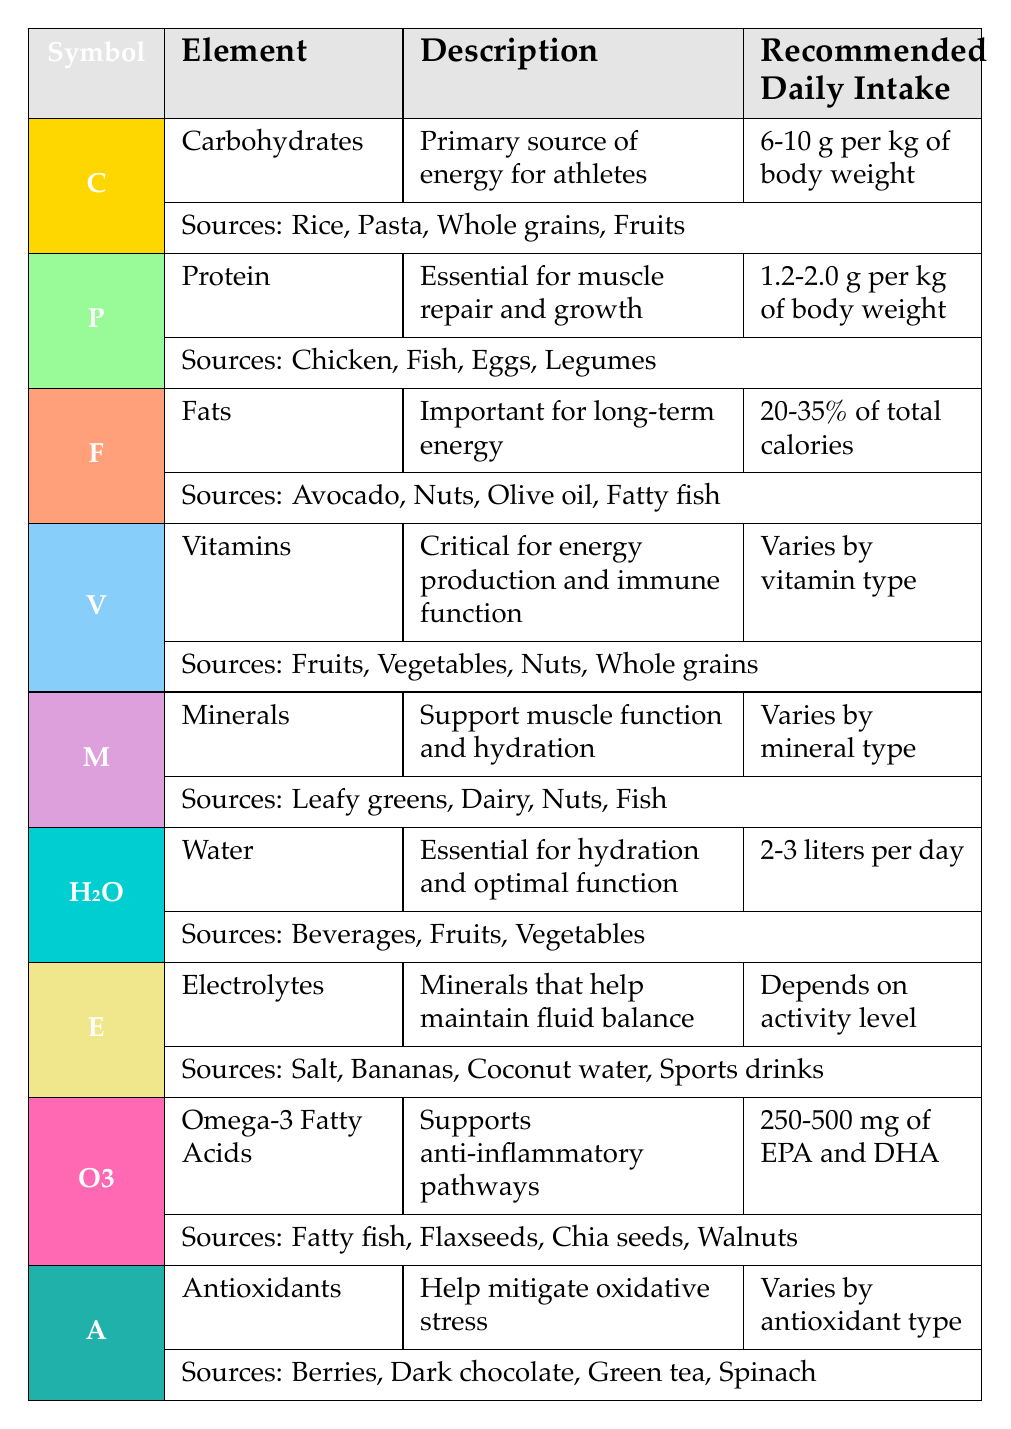What is the recommended daily intake of carbohydrates for athletes? The table specifies that the recommended daily intake of carbohydrates is 6-10 grams per kg of body weight. This can be directly found in the row for carbohydrates.
Answer: 6-10 grams per kg of body weight Which element is essential for muscle repair and growth? The table shows that protein is essential for muscle repair and growth, as stated in the description for protein.
Answer: Protein What is the primary source of energy for athletes? According to the table, carbohydrates are the primary source of energy for athletes, as highlighted in the carbohydrates' description.
Answer: Carbohydrates True or False: Fats are important for short-term energy needs in athletes. The table indicates that fats are important for long-term energy, especially in endurance sports, making the statement false.
Answer: False How many liters of water should athletes consume daily? The table states that athletes should consume 2-3 liters of water per day, which is clearly mentioned in the water section.
Answer: 2-3 liters per day What are the sources of Omega-3 fatty acids? The table lists the sources of Omega-3 fatty acids as fatty fish, flaxseeds, chia seeds, and walnuts, which can be found under the Omega-3 fatty acids row.
Answer: Fatty fish, flaxseeds, chia seeds, walnuts What percentage of total calories should come from fats? According to the table, the recommended daily intake for fats is 20-35% of total calories, which is specified in the fats section.
Answer: 20-35% of total calories What is the daily recommended intake of electrolytes based on activity level? The table indicates that the recommended daily intake of electrolytes depends on the activity level, as mentioned in the electrolytes' section. Thus, it cannot be specified as a fixed value.
Answer: Depends on activity level If an athlete weighs 70 kg, how many grams of protein should they ideally consume per day? To find the daily protein intake, multiply the weight (70 kg) by the recommended intake range: for 1.2 grams per kg, it would be 70 kg * 1.2 g/kg = 84 grams; for 2.0 grams per kg, it would be 70 kg * 2.0 g/kg = 140 grams. Therefore, the range would be 84-140 grams.
Answer: 84-140 grams per day 